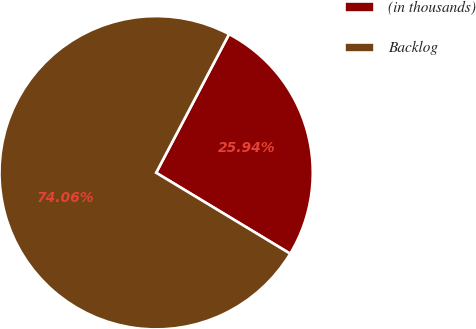Convert chart. <chart><loc_0><loc_0><loc_500><loc_500><pie_chart><fcel>(in thousands)<fcel>Backlog<nl><fcel>25.94%<fcel>74.06%<nl></chart> 